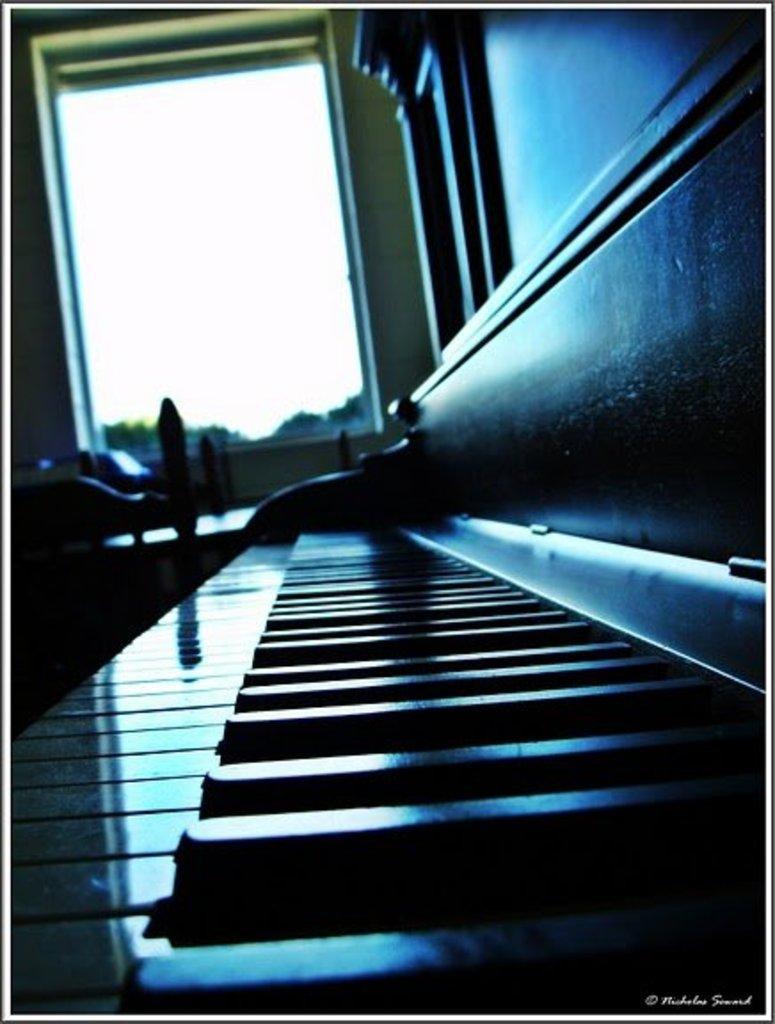Describe this image in one or two sentences. In the image we can see the keyboard. And coming to the background we can see the wall with the glass window. 